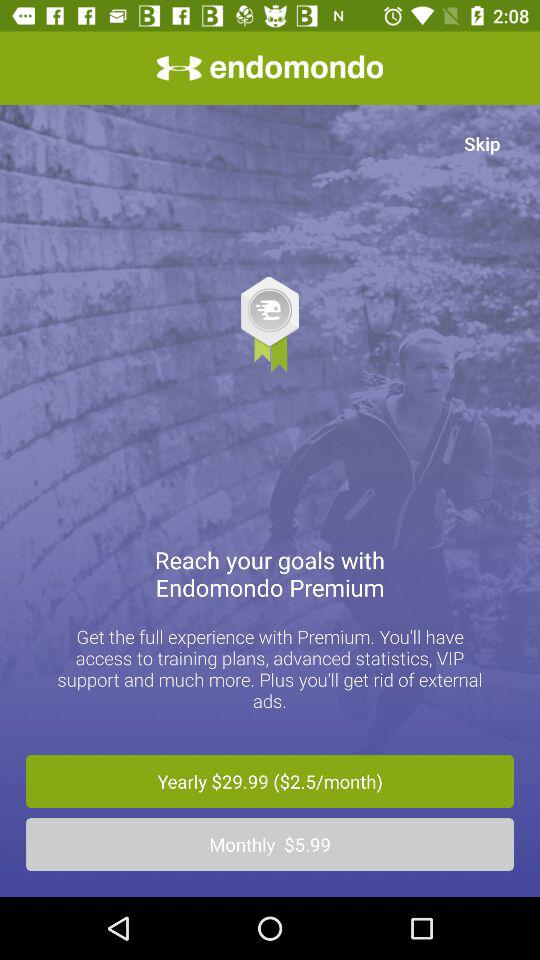What is the application name? The application name is "endomondo". 